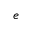Convert formula to latex. <formula><loc_0><loc_0><loc_500><loc_500>e</formula> 